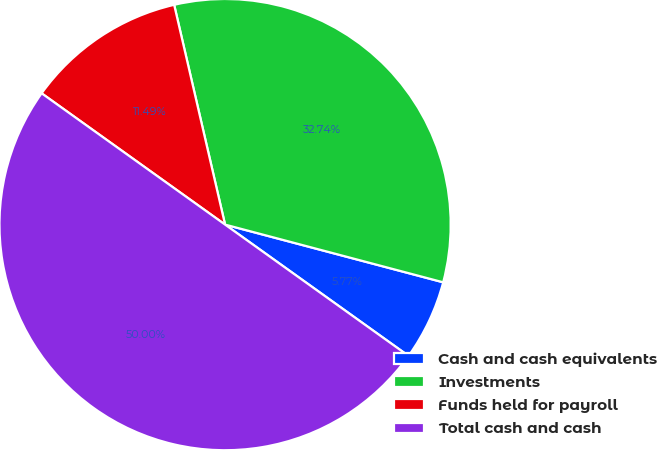<chart> <loc_0><loc_0><loc_500><loc_500><pie_chart><fcel>Cash and cash equivalents<fcel>Investments<fcel>Funds held for payroll<fcel>Total cash and cash<nl><fcel>5.77%<fcel>32.74%<fcel>11.49%<fcel>50.0%<nl></chart> 